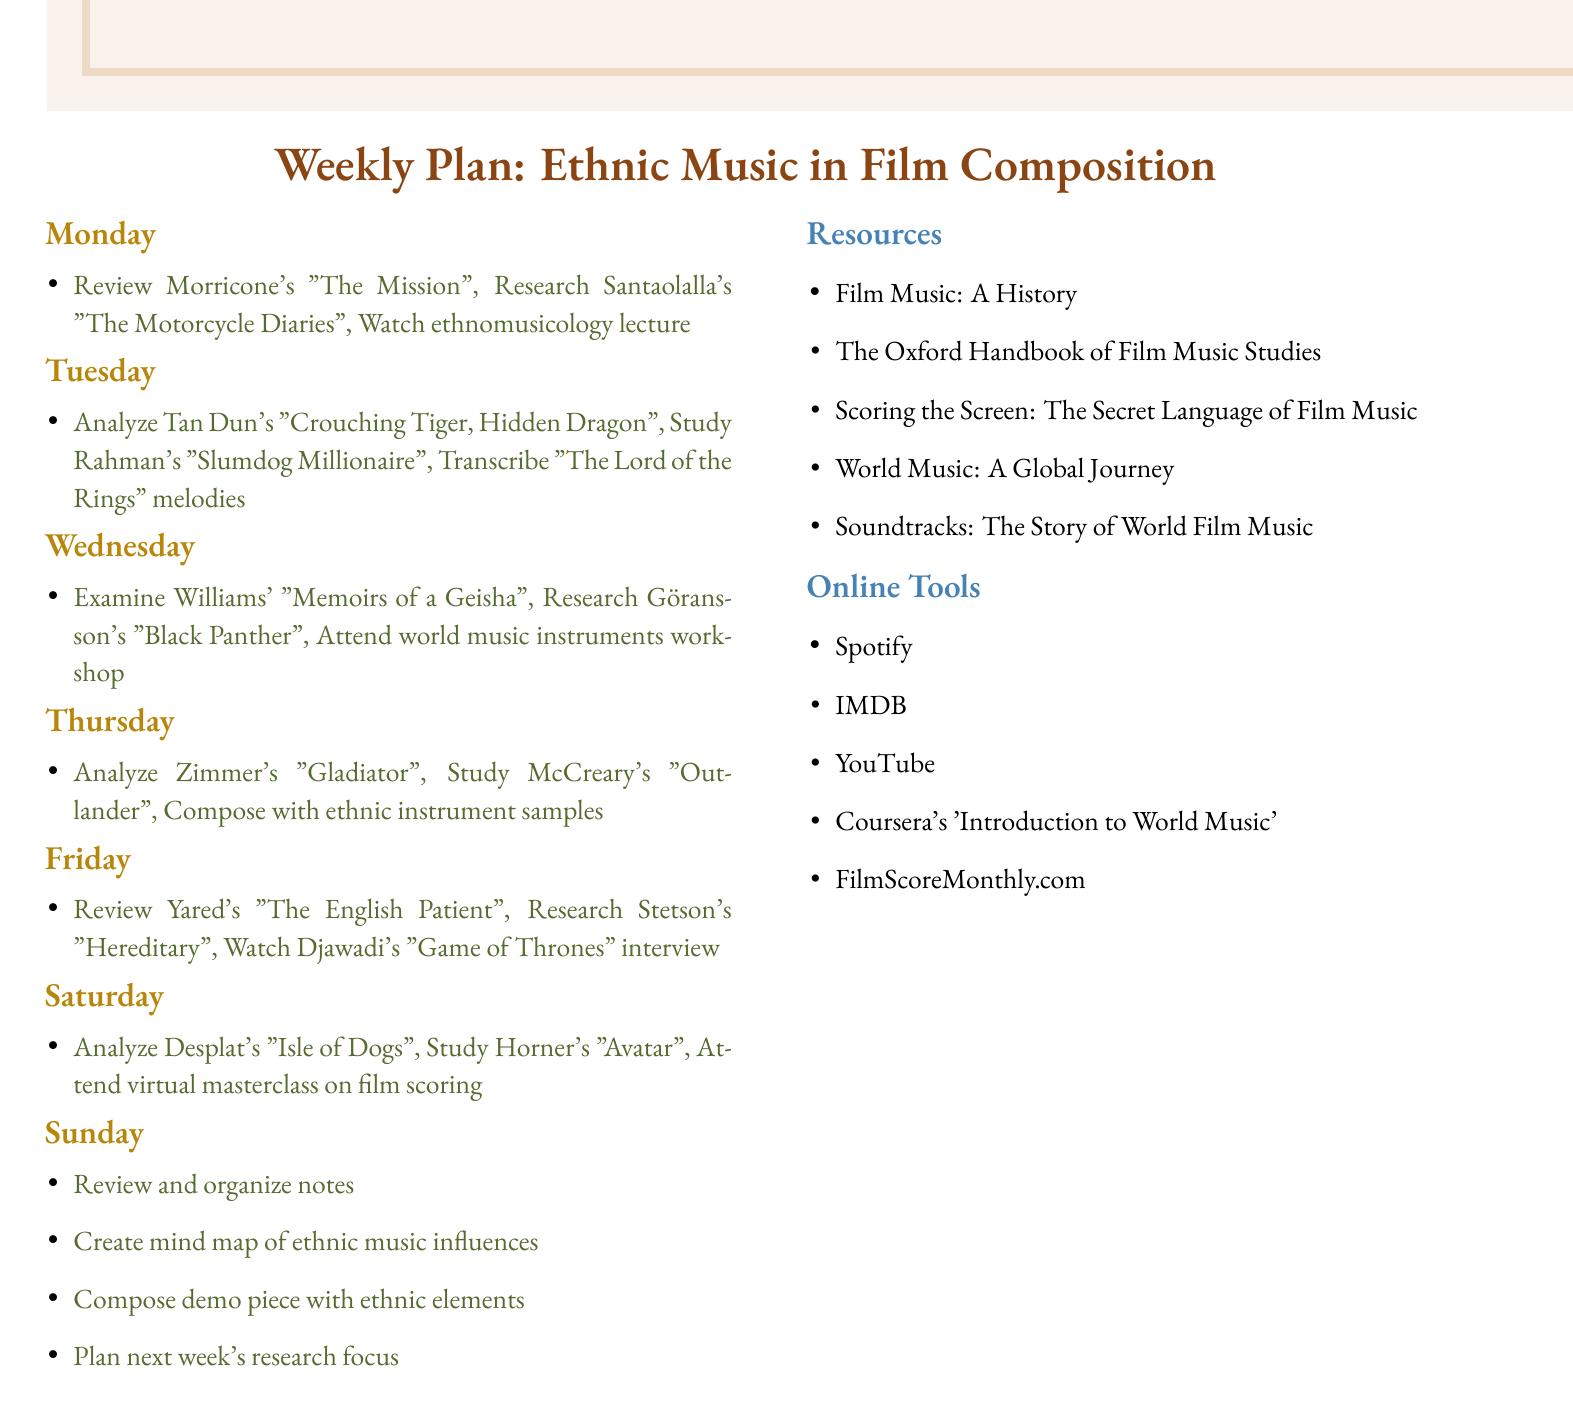What is the focus of the weekly plan? The weekly plan focuses on researching and analyzing film scores that incorporate traditional music from various cultures.
Answer: Ethnic music in film composition How many days are included in the plan? The plan outlines tasks for each day of the week, which totals to seven days.
Answer: Seven days Which composer is associated with the film 'The Mission'? The document lists Ennio Morricone as the composer for 'The Mission'.
Answer: Ennio Morricone What traditional music elements are studied on Tuesday? The plan specifies A.R. Rahman's incorporation of Carnatic music in 'Slumdog Millionaire'.
Answer: Carnatic music Which tool is recommended for listening to film scores? The document suggests using Spotify as an online tool for listening to film scores and world music playlists.
Answer: Spotify What activity is scheduled for Sunday? The plan includes the activity of reviewing and organizing notes from the week's research.
Answer: Review and organize notes Which score features the use of Indonesian gamelan? The document notes that Colin Stetson's score for 'Hereditary' incorporates Indonesian gamelan.
Answer: 'Hereditary' Name a resource mentioned for studying film music. The document lists "Film Music: A History" as one of the resources.
Answer: Film Music: A History What is the subject of the online workshop on Wednesday? The workshop hosted by Berklee College of Music focuses on world music instruments.
Answer: World music instruments 